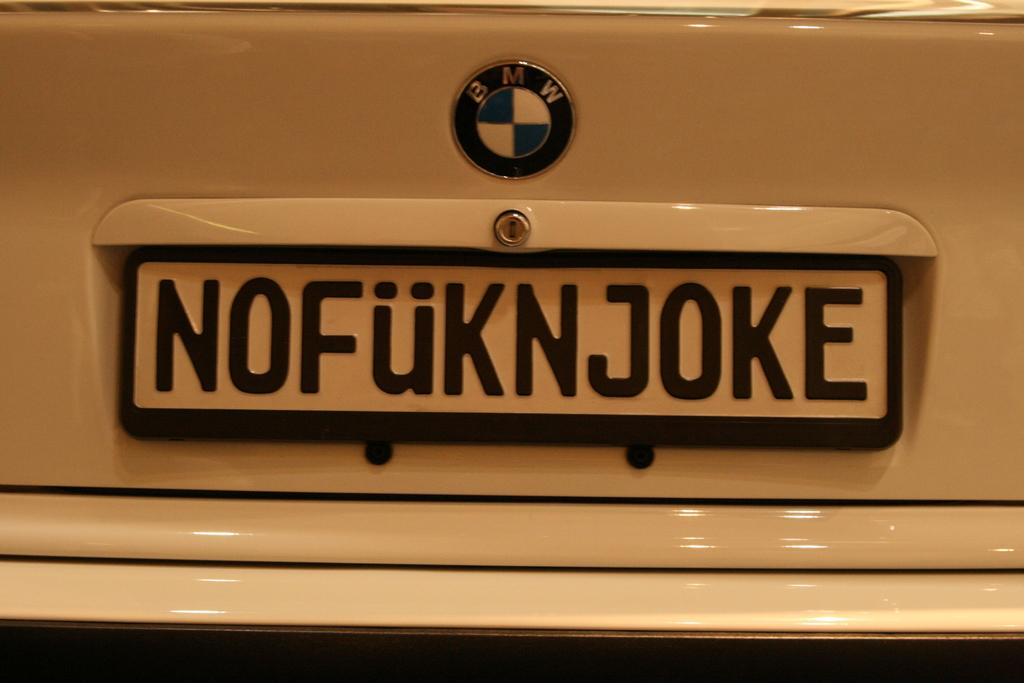<image>
Render a clear and concise summary of the photo. A BMW is shown with a crude license plate 